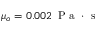Convert formula to latex. <formula><loc_0><loc_0><loc_500><loc_500>\mu _ { o } = 0 . 0 0 2 \, P a \cdot s</formula> 